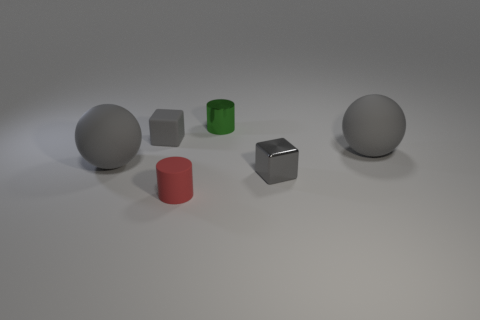Is there a small red cylinder that has the same material as the tiny green thing?
Offer a very short reply. No. Are the big gray sphere left of the small red rubber cylinder and the cube that is on the right side of the green shiny cylinder made of the same material?
Offer a terse response. No. How many big gray objects are there?
Offer a terse response. 2. There is a big gray rubber object left of the tiny shiny cylinder; what shape is it?
Your response must be concise. Sphere. How many other objects are there of the same size as the green metallic thing?
Provide a succinct answer. 3. Does the green thing that is to the right of the tiny rubber cylinder have the same shape as the gray thing that is left of the gray rubber block?
Keep it short and to the point. No. How many red matte cylinders are to the left of the green metallic cylinder?
Your response must be concise. 1. There is a ball that is to the right of the tiny green metal cylinder; what is its color?
Ensure brevity in your answer.  Gray. The small rubber object that is the same shape as the tiny gray metal thing is what color?
Offer a very short reply. Gray. Is there any other thing that is the same color as the shiny cylinder?
Provide a succinct answer. No. 